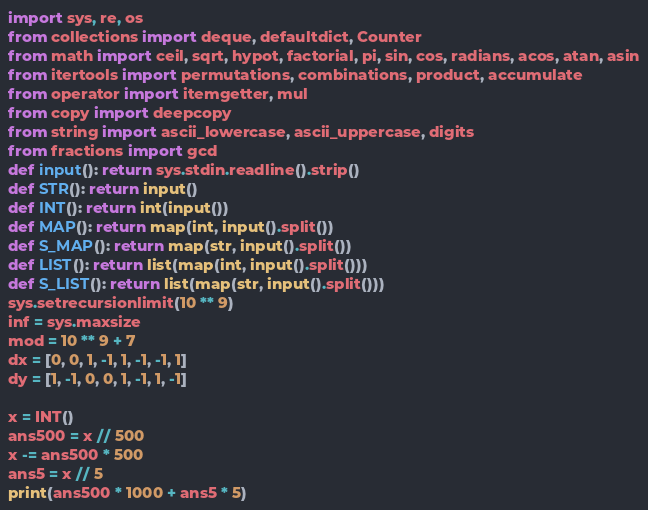Convert code to text. <code><loc_0><loc_0><loc_500><loc_500><_Python_>import sys, re, os
from collections import deque, defaultdict, Counter
from math import ceil, sqrt, hypot, factorial, pi, sin, cos, radians, acos, atan, asin
from itertools import permutations, combinations, product, accumulate
from operator import itemgetter, mul
from copy import deepcopy
from string import ascii_lowercase, ascii_uppercase, digits
from fractions import gcd
def input(): return sys.stdin.readline().strip()
def STR(): return input()
def INT(): return int(input())
def MAP(): return map(int, input().split())
def S_MAP(): return map(str, input().split())
def LIST(): return list(map(int, input().split()))
def S_LIST(): return list(map(str, input().split()))
sys.setrecursionlimit(10 ** 9)
inf = sys.maxsize
mod = 10 ** 9 + 7
dx = [0, 0, 1, -1, 1, -1, -1, 1]
dy = [1, -1, 0, 0, 1, -1, 1, -1]

x = INT()
ans500 = x // 500
x -= ans500 * 500
ans5 = x // 5
print(ans500 * 1000 + ans5 * 5)</code> 